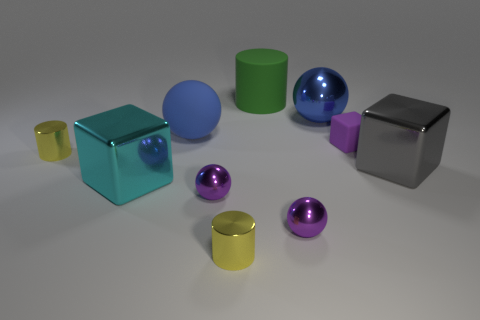What size is the metal ball that is the same color as the large matte sphere?
Offer a terse response. Large. How many large rubber spheres have the same color as the big metal sphere?
Your answer should be compact. 1. Is there a green rubber cylinder of the same size as the cyan thing?
Provide a short and direct response. Yes. What number of things are big blue metal balls behind the big gray object or small yellow cylinders?
Make the answer very short. 3. Is the material of the cyan block the same as the cylinder behind the small matte object?
Offer a terse response. No. What number of other objects are there of the same shape as the cyan thing?
Make the answer very short. 2. How many things are yellow shiny cylinders on the right side of the big cyan metallic thing or yellow things that are in front of the cyan object?
Offer a terse response. 1. How many other objects are there of the same color as the rubber cube?
Your answer should be very brief. 2. Is the number of tiny yellow metal cylinders on the left side of the large cyan object less than the number of objects on the right side of the blue shiny object?
Offer a terse response. Yes. What number of big cyan objects are there?
Give a very brief answer. 1. 